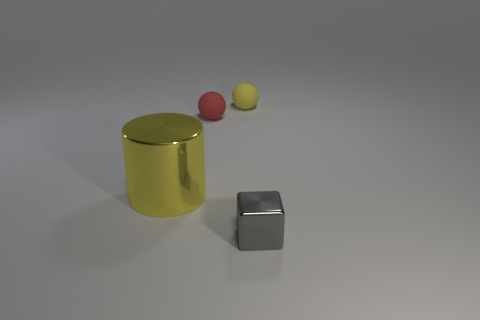How many objects are things behind the big thing or large yellow metallic cylinders?
Provide a short and direct response. 3. There is a object that is in front of the red sphere and right of the large metal cylinder; what shape is it?
Offer a very short reply. Cube. What number of objects are either tiny objects that are behind the tiny block or metallic objects in front of the big yellow shiny cylinder?
Give a very brief answer. 3. How many other things are the same size as the yellow matte sphere?
Your answer should be compact. 2. Is the color of the shiny thing behind the tiny gray shiny cube the same as the tiny cube?
Ensure brevity in your answer.  No. There is a object that is both right of the yellow metal cylinder and in front of the red thing; what is its size?
Offer a very short reply. Small. What number of large objects are matte things or red blocks?
Offer a terse response. 0. What shape is the metallic thing that is behind the small metal block?
Your answer should be very brief. Cylinder. How many blocks are there?
Provide a short and direct response. 1. Is the big yellow object made of the same material as the red ball?
Offer a terse response. No. 